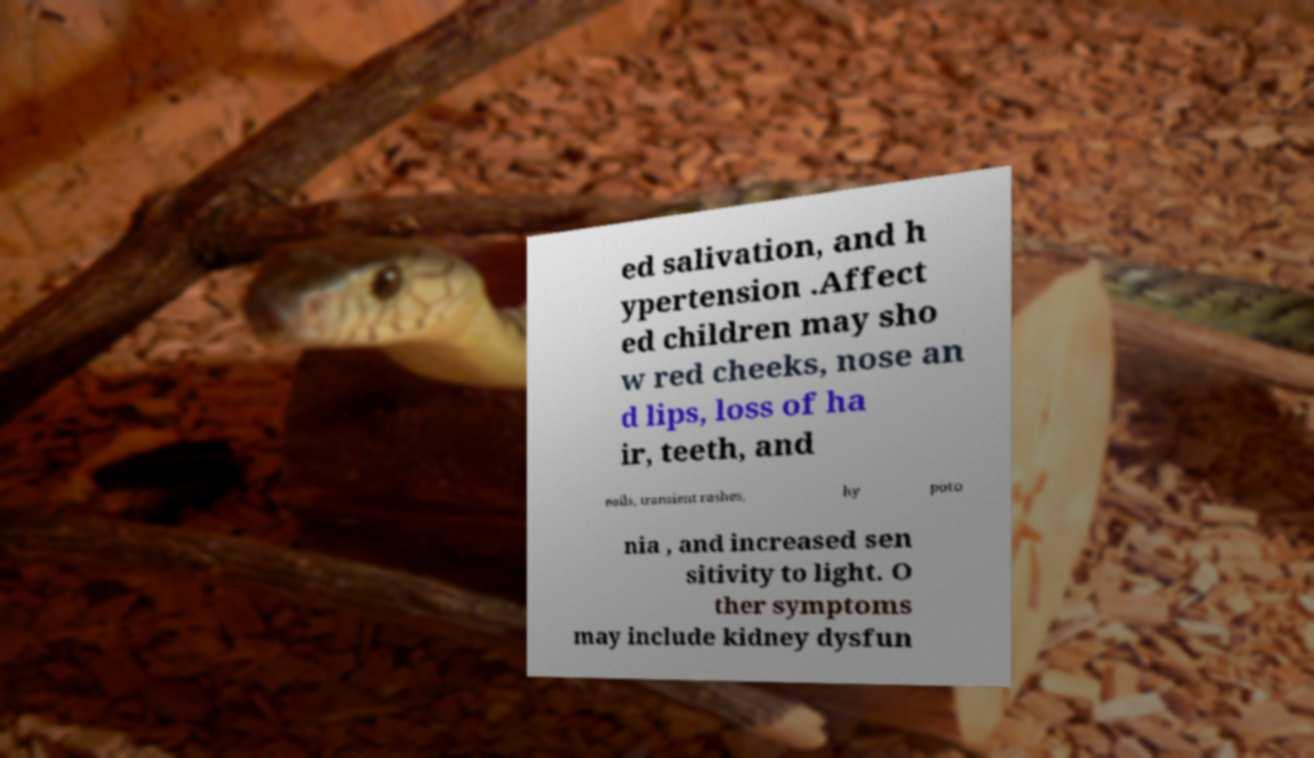Can you accurately transcribe the text from the provided image for me? ed salivation, and h ypertension .Affect ed children may sho w red cheeks, nose an d lips, loss of ha ir, teeth, and nails, transient rashes, hy poto nia , and increased sen sitivity to light. O ther symptoms may include kidney dysfun 